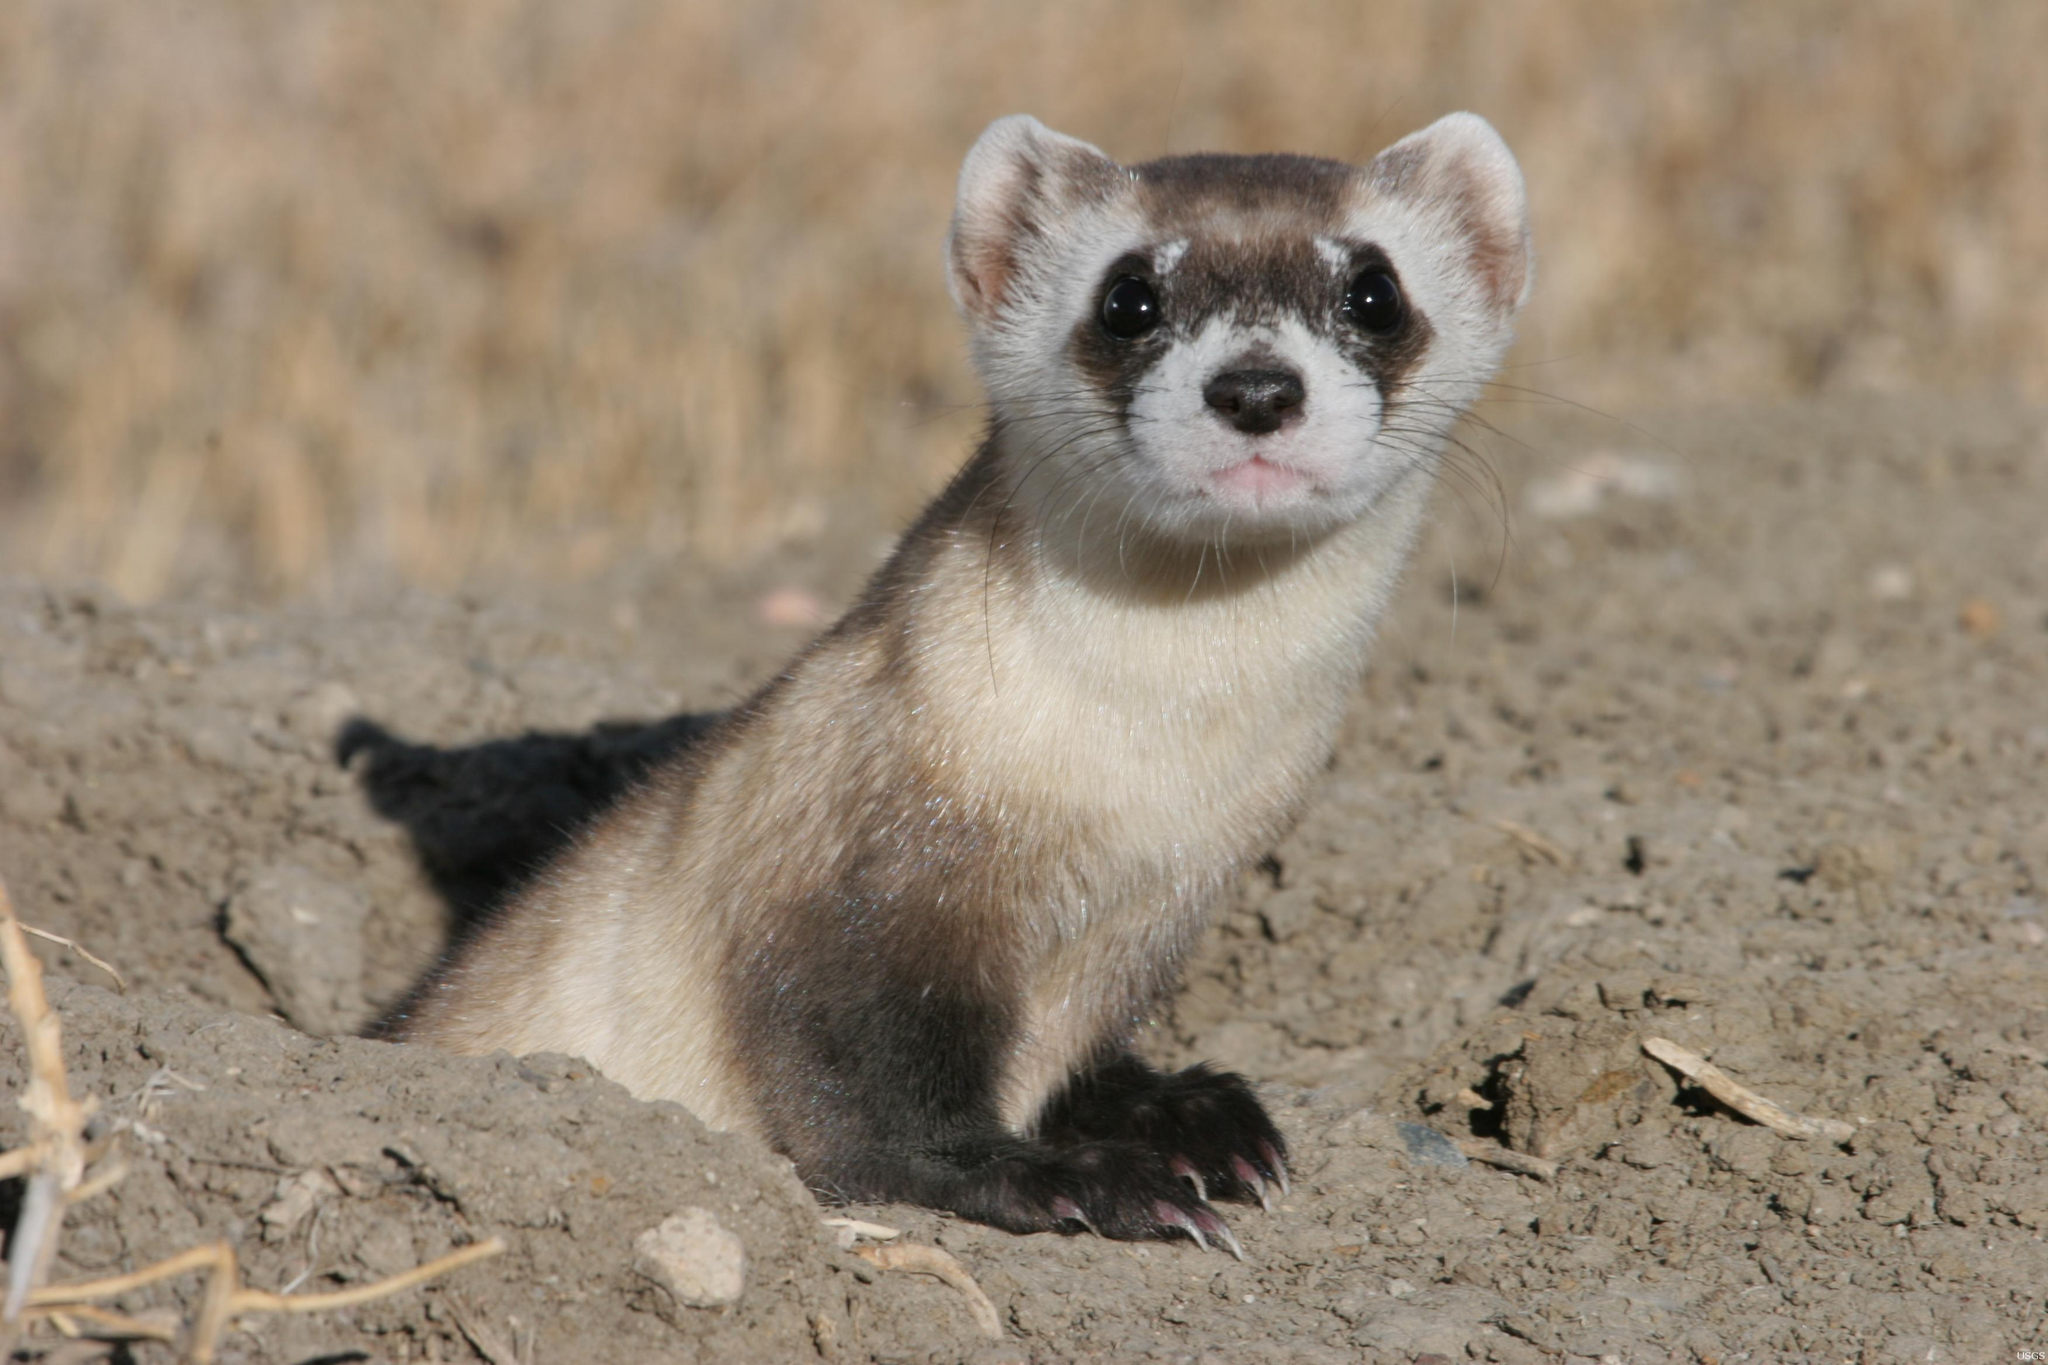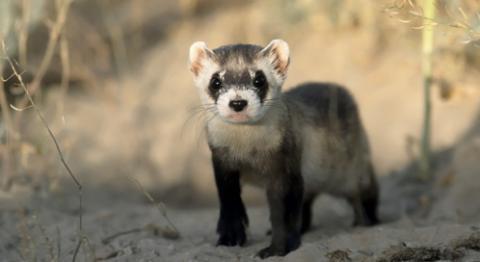The first image is the image on the left, the second image is the image on the right. For the images displayed, is the sentence "An animal is looking to the left." factually correct? Answer yes or no. No. The first image is the image on the left, the second image is the image on the right. Assess this claim about the two images: "Right and left images show ferrets with heads facing the same direction.". Correct or not? Answer yes or no. Yes. 